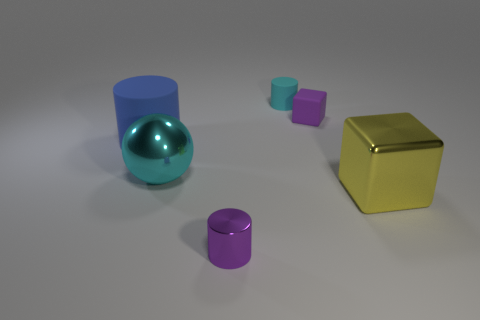Is there anything else that is the same shape as the cyan shiny thing?
Provide a succinct answer. No. What size is the metallic cube?
Ensure brevity in your answer.  Large. There is a blue object that is the same size as the ball; what is its shape?
Your response must be concise. Cylinder. Is the large cyan thing made of the same material as the tiny purple cylinder?
Give a very brief answer. Yes. What number of matte objects are either yellow blocks or small cyan balls?
Your response must be concise. 0. What shape is the small object that is the same color as the tiny metallic cylinder?
Your answer should be compact. Cube. Do the matte cylinder that is behind the rubber block and the metal cylinder have the same color?
Give a very brief answer. No. The rubber object on the left side of the metal object that is in front of the yellow thing is what shape?
Provide a succinct answer. Cylinder. How many things are cubes that are behind the metallic cube or tiny things behind the big blue rubber cylinder?
Ensure brevity in your answer.  2. There is a tiny cyan object that is the same material as the big cylinder; what is its shape?
Make the answer very short. Cylinder. 